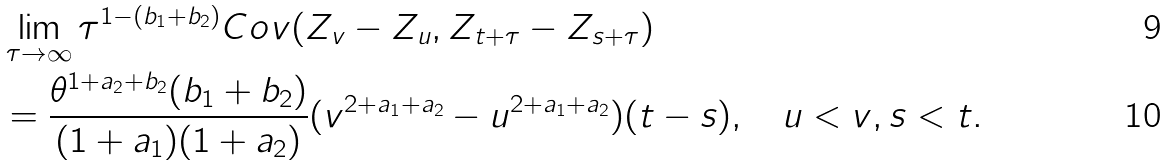Convert formula to latex. <formula><loc_0><loc_0><loc_500><loc_500>& \lim _ { \tau \to \infty } \tau ^ { 1 - ( b _ { 1 } + b _ { 2 } ) } C o v ( Z _ { v } - Z _ { u } , Z _ { t + \tau } - Z _ { s + \tau } ) \\ & = \frac { \theta ^ { 1 + a _ { 2 } + b _ { 2 } } ( b _ { 1 } + b _ { 2 } ) } { ( 1 + a _ { 1 } ) ( 1 + a _ { 2 } ) } ( v ^ { 2 + a _ { 1 } + a _ { 2 } } - u ^ { 2 + a _ { 1 } + a _ { 2 } } ) ( t - s ) , \ \ \ u < v , s < t .</formula> 